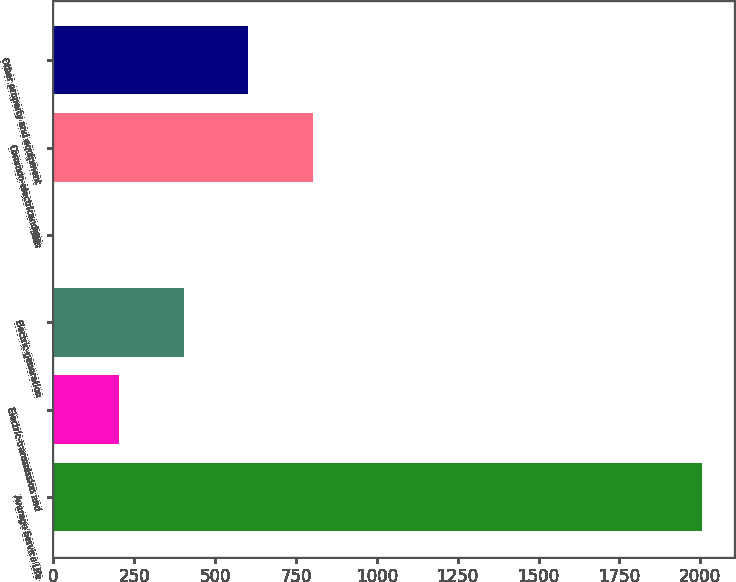Convert chart to OTSL. <chart><loc_0><loc_0><loc_500><loc_500><bar_chart><fcel>Average Service Life<fcel>Electric-transmission and<fcel>Electric-generation<fcel>Gas<fcel>Common-electricandgas<fcel>Other property and equipment<nl><fcel>2005<fcel>202.59<fcel>402.86<fcel>2.32<fcel>803.4<fcel>603.13<nl></chart> 